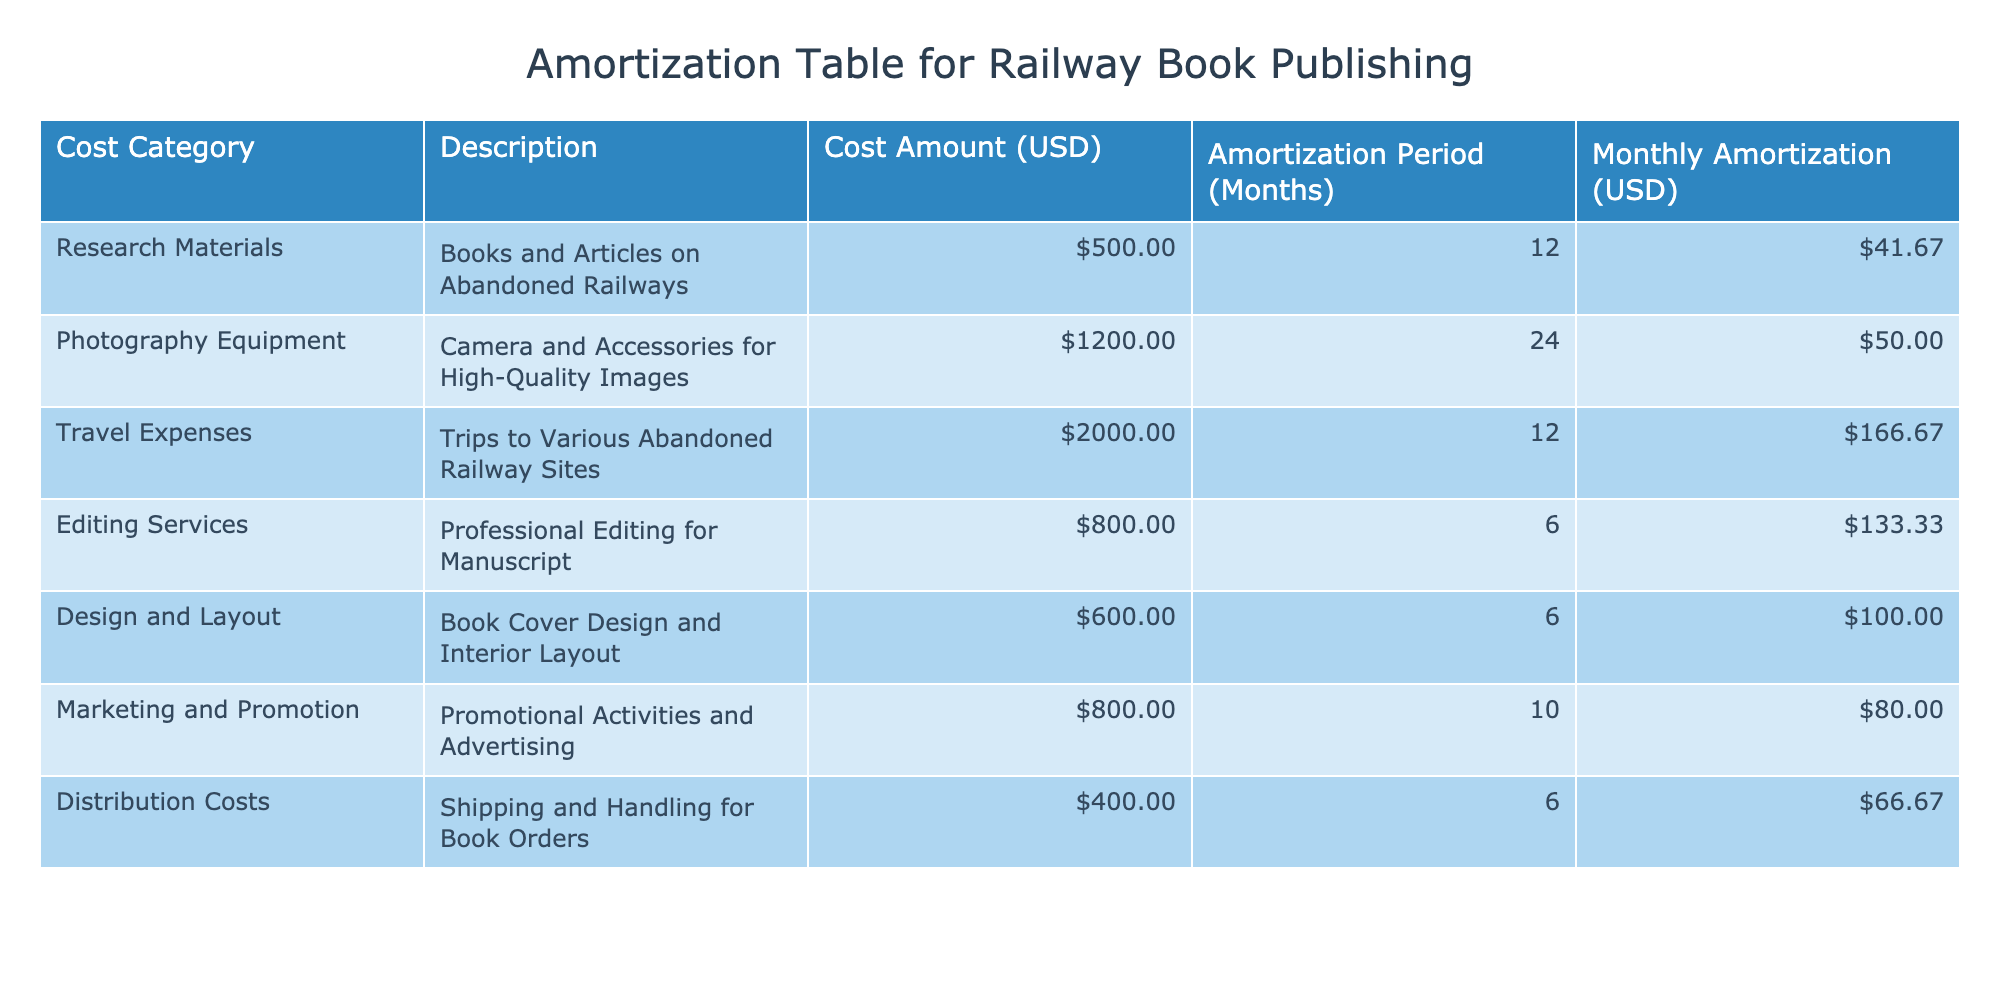What is the total cost for editing services? According to the table, the cost for editing services is listed as 800 USD.
Answer: 800 USD What is the monthly amortization cost for travel expenses? The table shows that the monthly amortization for travel expenses is 166.67 USD.
Answer: 166.67 USD Which cost category has the highest total amount? The highest cost amount is for "Travel Expenses," totaling 2000 USD, as indicated in the second column of the table.
Answer: Travel Expenses What is the total monthly amortization for the book's research materials and design and layout combined? The monthly amortization for research materials is 41.67 USD, and for design and layout, it is 100.00 USD. Summing these gives 41.67 + 100.00 = 141.67 USD.
Answer: 141.67 USD Is the monthly amortization for marketing and promotion greater than that for distribution costs? The monthly amortization for marketing and promotion is 80.00 USD, while for distribution costs it is 66.67 USD. Since 80.00 is greater than 66.67, the statement is true.
Answer: Yes What is the average monthly amortization across all cost categories? To find the average, first sum the monthly amortization values: 41.67 + 50.00 + 166.67 + 133.33 + 100.00 + 80.00 + 66.67 = 638.34 USD. Then, divide by the number of categories (7): 638.34 / 7 ≈ 91.19.
Answer: Approximately 91.19 USD How much more does photography equipment cost compared to research materials? The cost for photography equipment is 1200 USD and for research materials it's 500 USD. The difference is calculated as 1200 - 500 = 700 USD.
Answer: 700 USD Which cost category has an amortization period of 6 months? The cost categories with an amortization period of 6 months are "Editing Services", "Design and Layout", and "Distribution Costs" as listed in the table.
Answer: Editing Services, Design and Layout, Distribution Costs What percentage of the total costs does travel expenses represent? First, sum all costs: 500 + 1200 + 2000 + 800 + 600 + 800 + 400 = 5300 USD. Then, calculate the percentage of travel expenses: (2000 / 5300) * 100 ≈ 37.74%.
Answer: Approximately 37.74% 